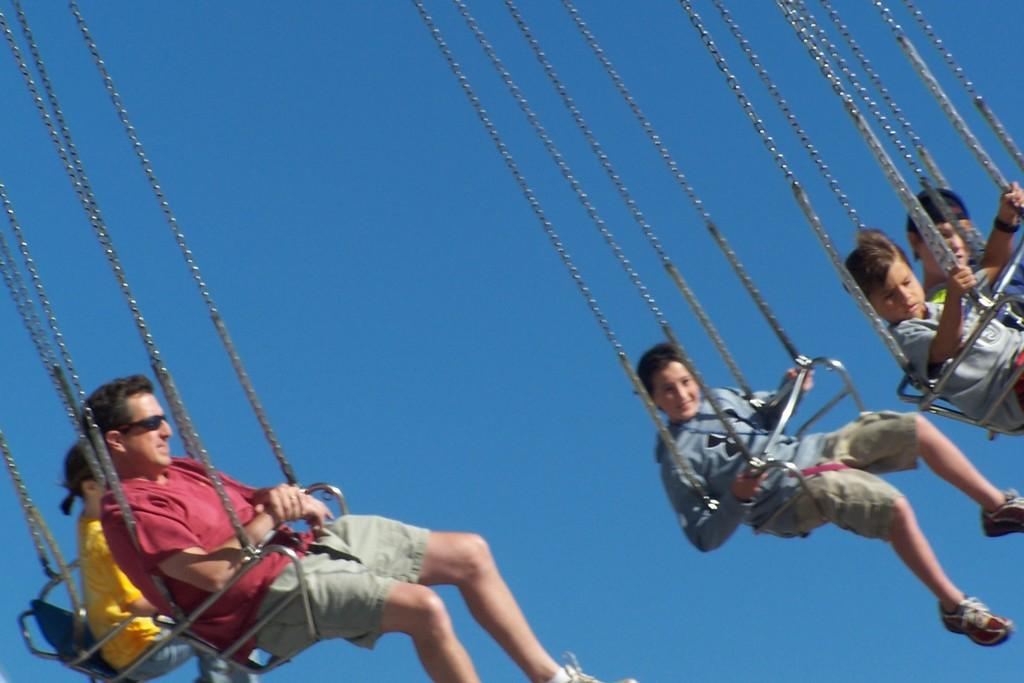What are the people in the image doing? The people in the image are sitting on chair swing rides. What can be seen in the background of the image? The sky is visible in the background of the image. Where is the shade provided by the mom in the image? A: There is no mention of a mom or shade in the image, so we cannot answer that question. 